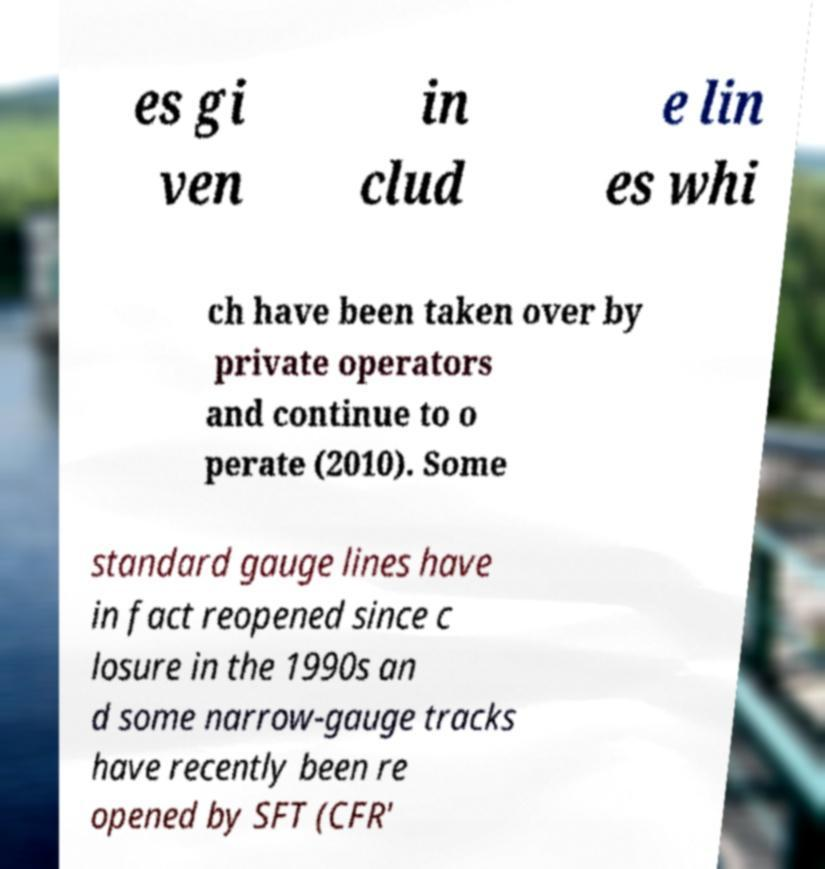Can you accurately transcribe the text from the provided image for me? es gi ven in clud e lin es whi ch have been taken over by private operators and continue to o perate (2010). Some standard gauge lines have in fact reopened since c losure in the 1990s an d some narrow-gauge tracks have recently been re opened by SFT (CFR' 